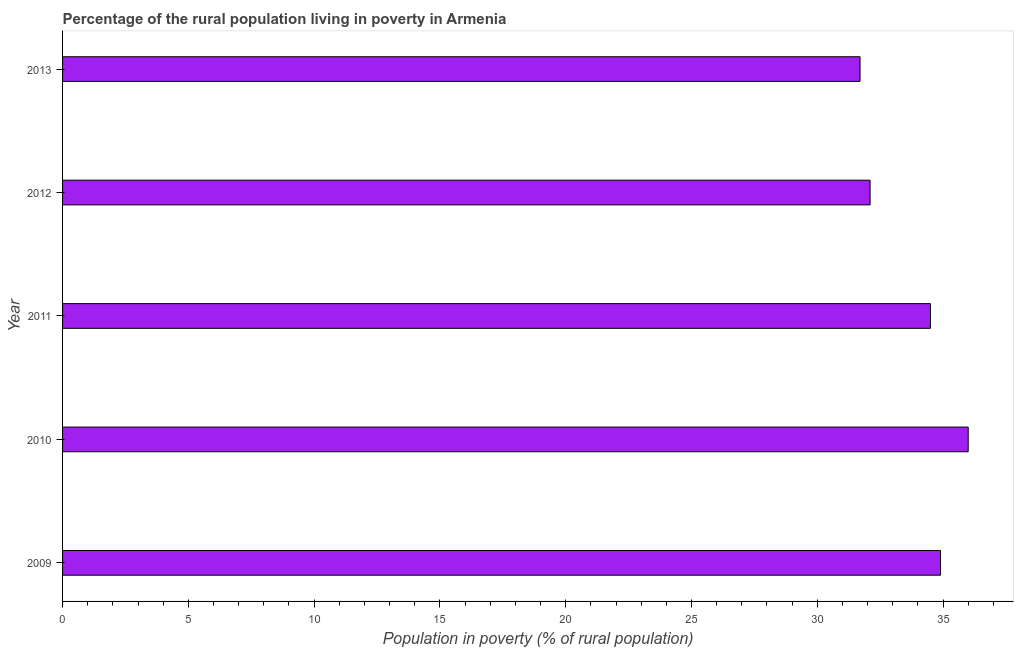Does the graph contain grids?
Give a very brief answer. No. What is the title of the graph?
Your answer should be very brief. Percentage of the rural population living in poverty in Armenia. What is the label or title of the X-axis?
Keep it short and to the point. Population in poverty (% of rural population). What is the label or title of the Y-axis?
Keep it short and to the point. Year. What is the percentage of rural population living below poverty line in 2012?
Give a very brief answer. 32.1. Across all years, what is the maximum percentage of rural population living below poverty line?
Ensure brevity in your answer.  36. Across all years, what is the minimum percentage of rural population living below poverty line?
Provide a short and direct response. 31.7. What is the sum of the percentage of rural population living below poverty line?
Provide a succinct answer. 169.2. What is the difference between the percentage of rural population living below poverty line in 2009 and 2011?
Ensure brevity in your answer.  0.4. What is the average percentage of rural population living below poverty line per year?
Keep it short and to the point. 33.84. What is the median percentage of rural population living below poverty line?
Provide a short and direct response. 34.5. In how many years, is the percentage of rural population living below poverty line greater than 5 %?
Your answer should be very brief. 5. What is the ratio of the percentage of rural population living below poverty line in 2011 to that in 2013?
Provide a succinct answer. 1.09. Is the percentage of rural population living below poverty line in 2011 less than that in 2012?
Your answer should be compact. No. What is the difference between the highest and the second highest percentage of rural population living below poverty line?
Give a very brief answer. 1.1. In how many years, is the percentage of rural population living below poverty line greater than the average percentage of rural population living below poverty line taken over all years?
Your answer should be compact. 3. How many bars are there?
Make the answer very short. 5. Are the values on the major ticks of X-axis written in scientific E-notation?
Keep it short and to the point. No. What is the Population in poverty (% of rural population) in 2009?
Give a very brief answer. 34.9. What is the Population in poverty (% of rural population) in 2011?
Offer a terse response. 34.5. What is the Population in poverty (% of rural population) of 2012?
Your answer should be very brief. 32.1. What is the Population in poverty (% of rural population) in 2013?
Your response must be concise. 31.7. What is the difference between the Population in poverty (% of rural population) in 2009 and 2010?
Provide a succinct answer. -1.1. What is the difference between the Population in poverty (% of rural population) in 2009 and 2012?
Your answer should be compact. 2.8. What is the difference between the Population in poverty (% of rural population) in 2010 and 2011?
Your answer should be very brief. 1.5. What is the difference between the Population in poverty (% of rural population) in 2010 and 2012?
Your response must be concise. 3.9. What is the difference between the Population in poverty (% of rural population) in 2011 and 2013?
Offer a very short reply. 2.8. What is the difference between the Population in poverty (% of rural population) in 2012 and 2013?
Keep it short and to the point. 0.4. What is the ratio of the Population in poverty (% of rural population) in 2009 to that in 2010?
Give a very brief answer. 0.97. What is the ratio of the Population in poverty (% of rural population) in 2009 to that in 2012?
Give a very brief answer. 1.09. What is the ratio of the Population in poverty (% of rural population) in 2009 to that in 2013?
Ensure brevity in your answer.  1.1. What is the ratio of the Population in poverty (% of rural population) in 2010 to that in 2011?
Your answer should be compact. 1.04. What is the ratio of the Population in poverty (% of rural population) in 2010 to that in 2012?
Provide a short and direct response. 1.12. What is the ratio of the Population in poverty (% of rural population) in 2010 to that in 2013?
Ensure brevity in your answer.  1.14. What is the ratio of the Population in poverty (% of rural population) in 2011 to that in 2012?
Give a very brief answer. 1.07. What is the ratio of the Population in poverty (% of rural population) in 2011 to that in 2013?
Keep it short and to the point. 1.09. 